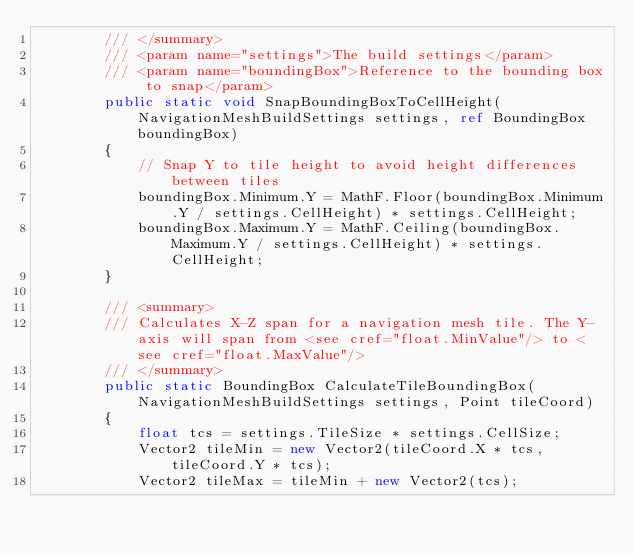<code> <loc_0><loc_0><loc_500><loc_500><_C#_>        /// </summary>
        /// <param name="settings">The build settings</param>
        /// <param name="boundingBox">Reference to the bounding box to snap</param>
        public static void SnapBoundingBoxToCellHeight(NavigationMeshBuildSettings settings, ref BoundingBox boundingBox)
        {
            // Snap Y to tile height to avoid height differences between tiles
            boundingBox.Minimum.Y = MathF.Floor(boundingBox.Minimum.Y / settings.CellHeight) * settings.CellHeight;
            boundingBox.Maximum.Y = MathF.Ceiling(boundingBox.Maximum.Y / settings.CellHeight) * settings.CellHeight;
        }

        /// <summary>
        /// Calculates X-Z span for a navigation mesh tile. The Y-axis will span from <see cref="float.MinValue"/> to <see cref="float.MaxValue"/>
        /// </summary>
        public static BoundingBox CalculateTileBoundingBox(NavigationMeshBuildSettings settings, Point tileCoord)
        {
            float tcs = settings.TileSize * settings.CellSize;
            Vector2 tileMin = new Vector2(tileCoord.X * tcs, tileCoord.Y * tcs);
            Vector2 tileMax = tileMin + new Vector2(tcs);
</code> 